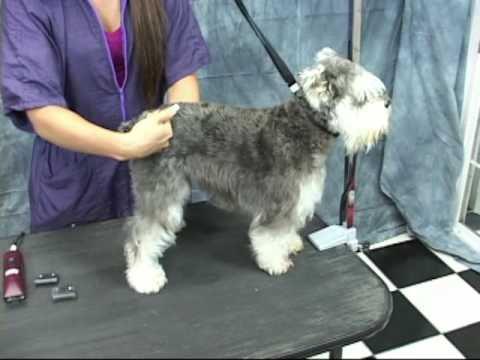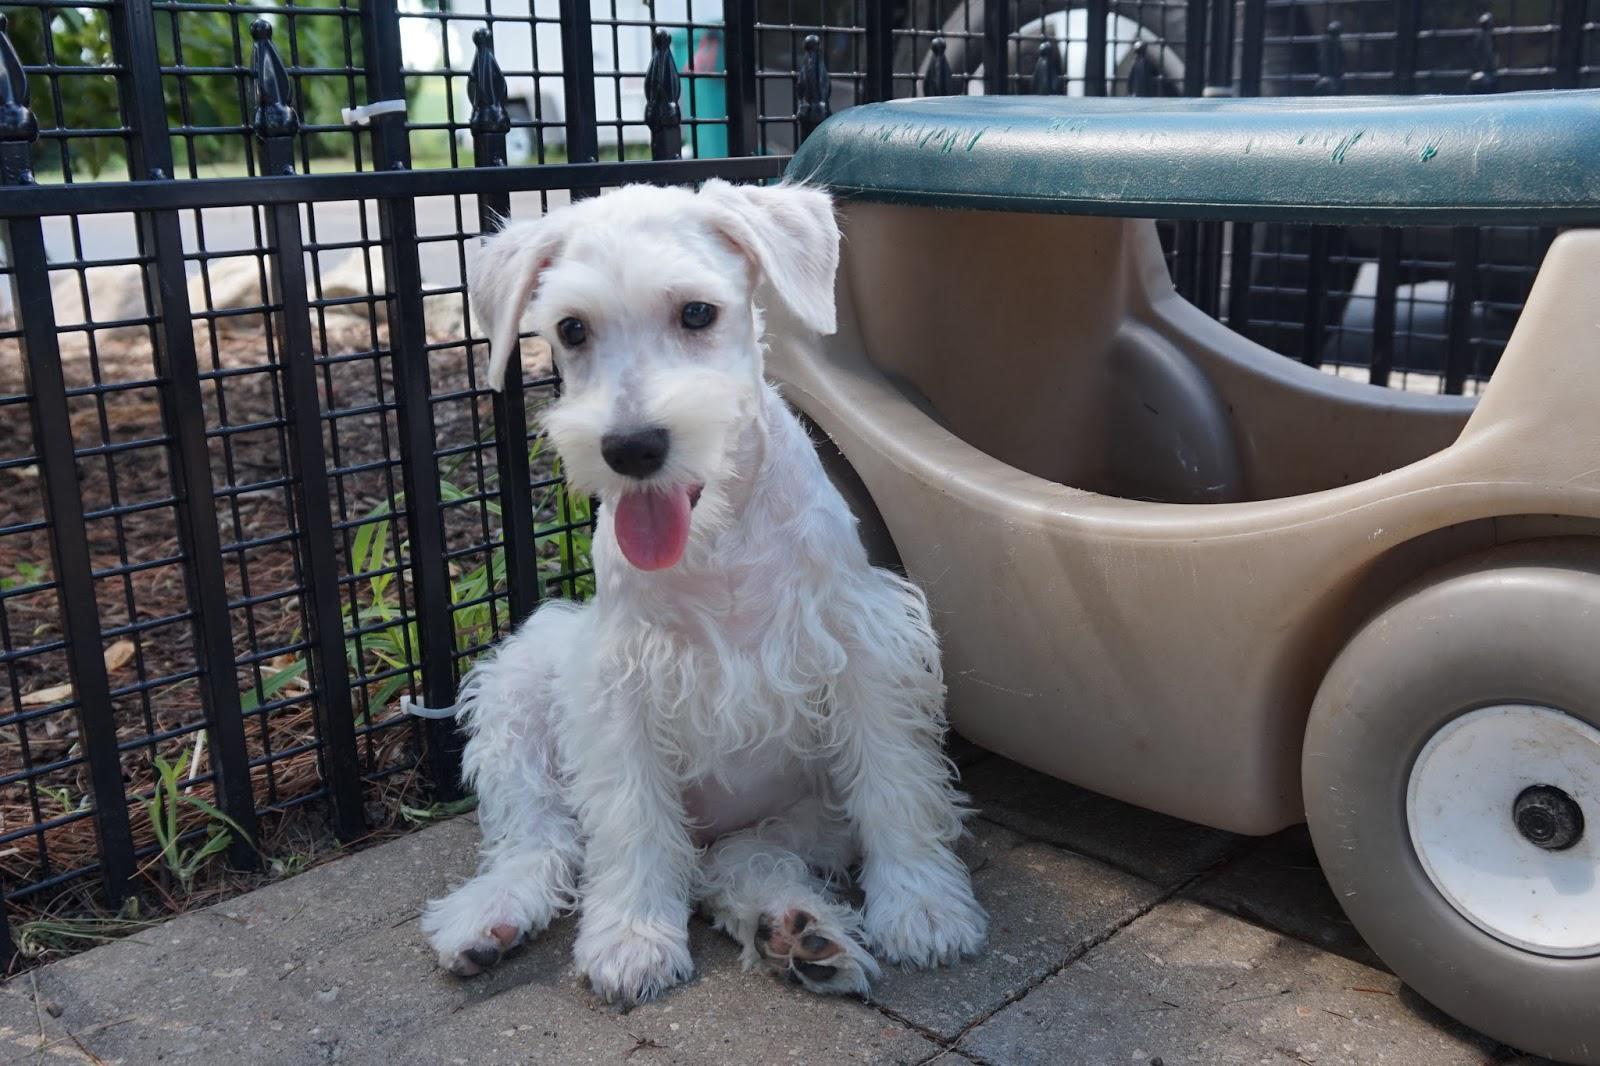The first image is the image on the left, the second image is the image on the right. Assess this claim about the two images: "There is a dog on grass in one of the iamges". Correct or not? Answer yes or no. No. 